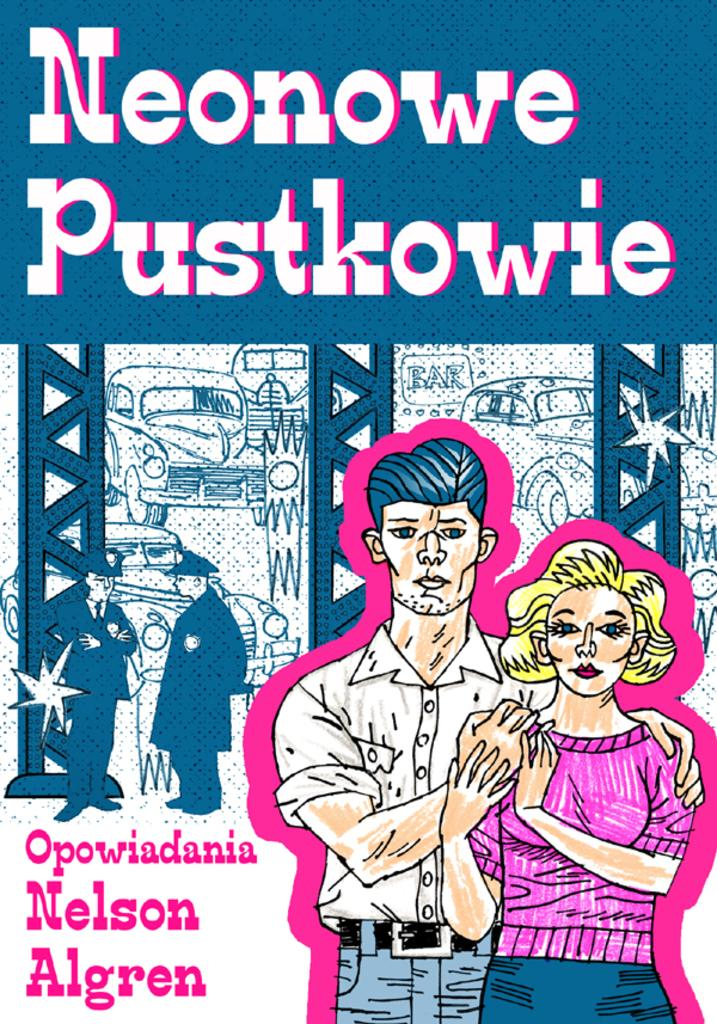What is present in the image that contains visual information? There is a poster in the image. What types of images can be seen on the poster? The poster contains pictures of persons and cars. Is there any text on the poster? Yes, there is text written on the poster. Where can the camp be seen in the image? There is no camp present in the image. What type of trousers are the persons wearing in the images on the poster? The images on the poster do not show the persons' trousers, so it cannot be determined from the image. 